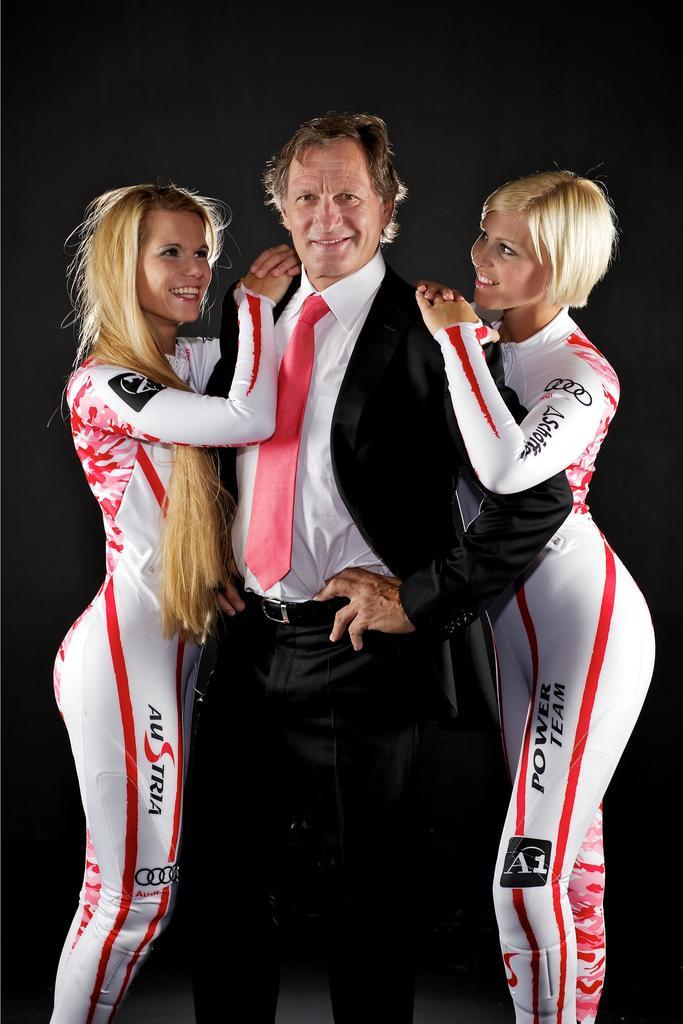<image>
Render a clear and concise summary of the photo. A Man in a black suit and red tie, in between two women who have on white suits that say Austria. 